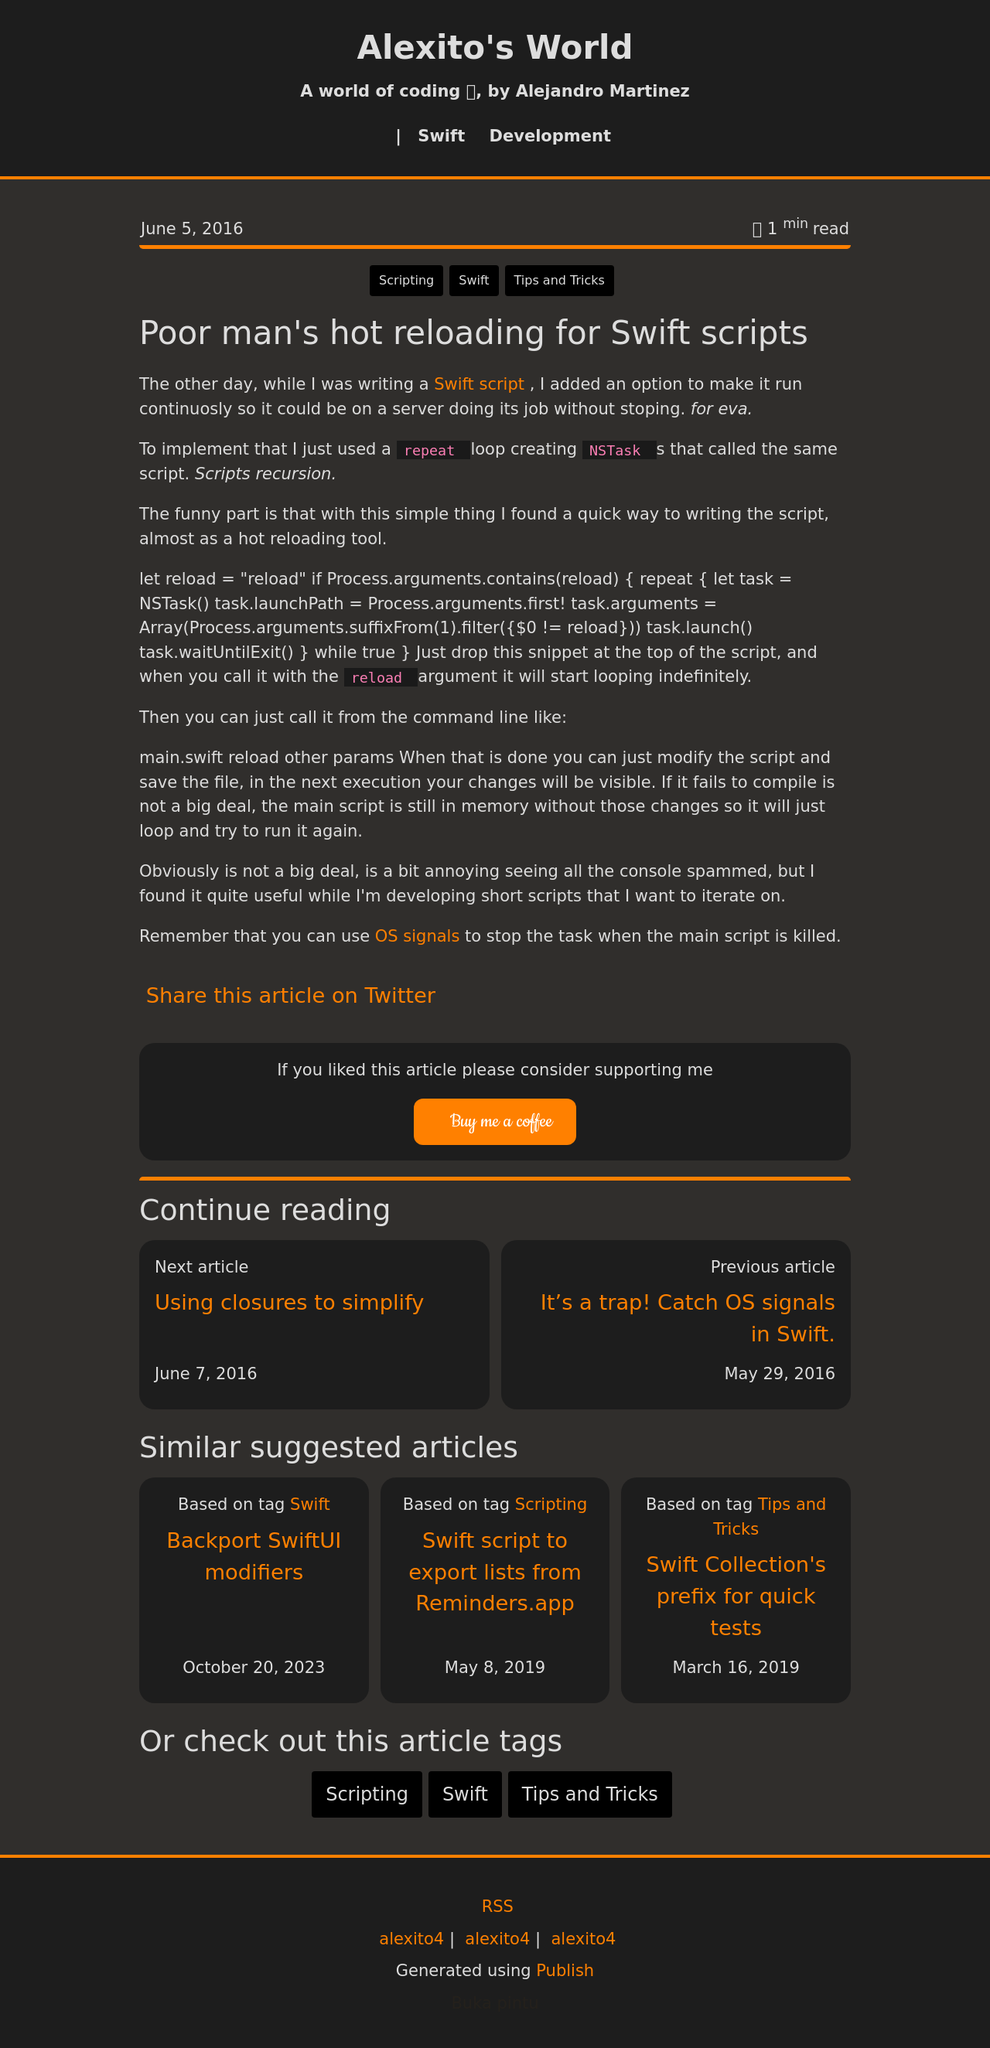Can you discuss the significance of the design choices made in the header of the website? The header of the website uses bold typography and a contrasting color scheme to draw attention. The use of black and orange creates a strong visual impact, ensuring that the site name and navigation are immediately noticeable. Such colors not only align with the overall dark aesthetic but also signify energy and creativity, which are likely characteristics of the site's content focussing on coding and development. This design choice may be aimed at making the site memorable and easily navigable. 